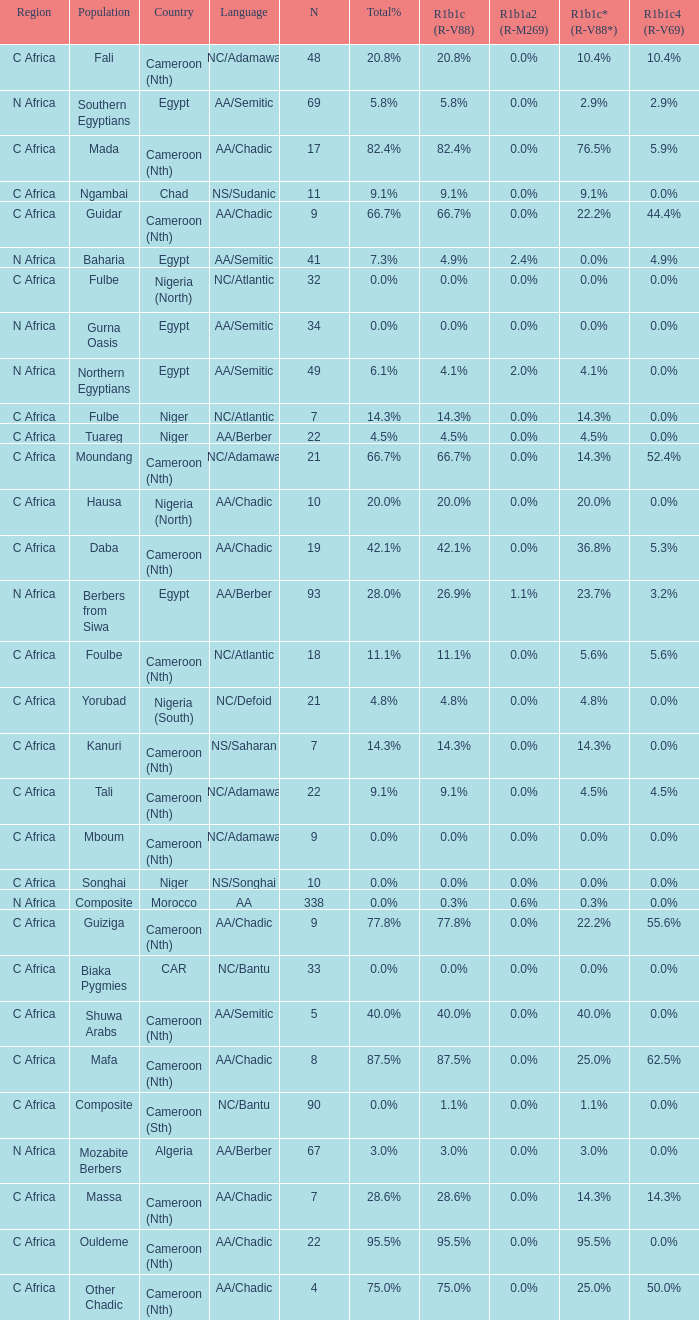What percentage is listed in column r1b1c (r-v88) for the 4.5% total percentage? 4.5%. 